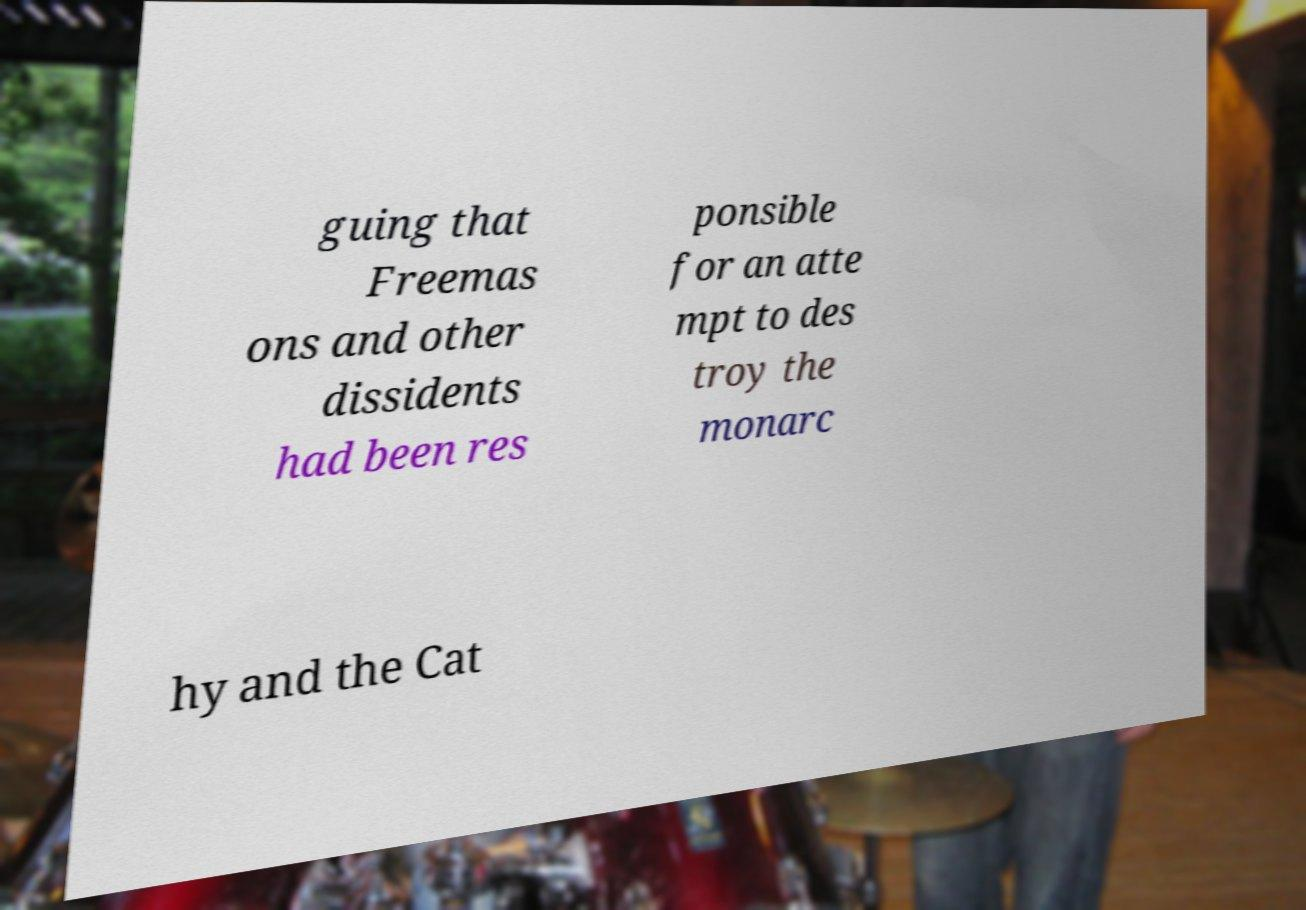There's text embedded in this image that I need extracted. Can you transcribe it verbatim? guing that Freemas ons and other dissidents had been res ponsible for an atte mpt to des troy the monarc hy and the Cat 